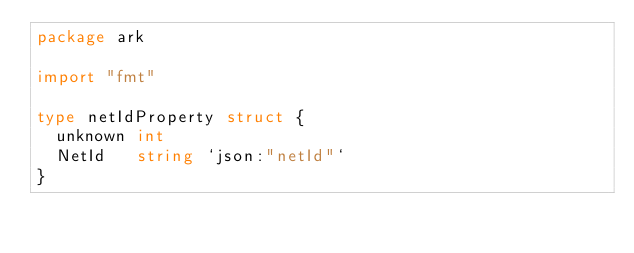<code> <loc_0><loc_0><loc_500><loc_500><_Go_>package ark

import "fmt"

type netIdProperty struct {
	unknown int
	NetId   string `json:"netId"`
}
</code> 